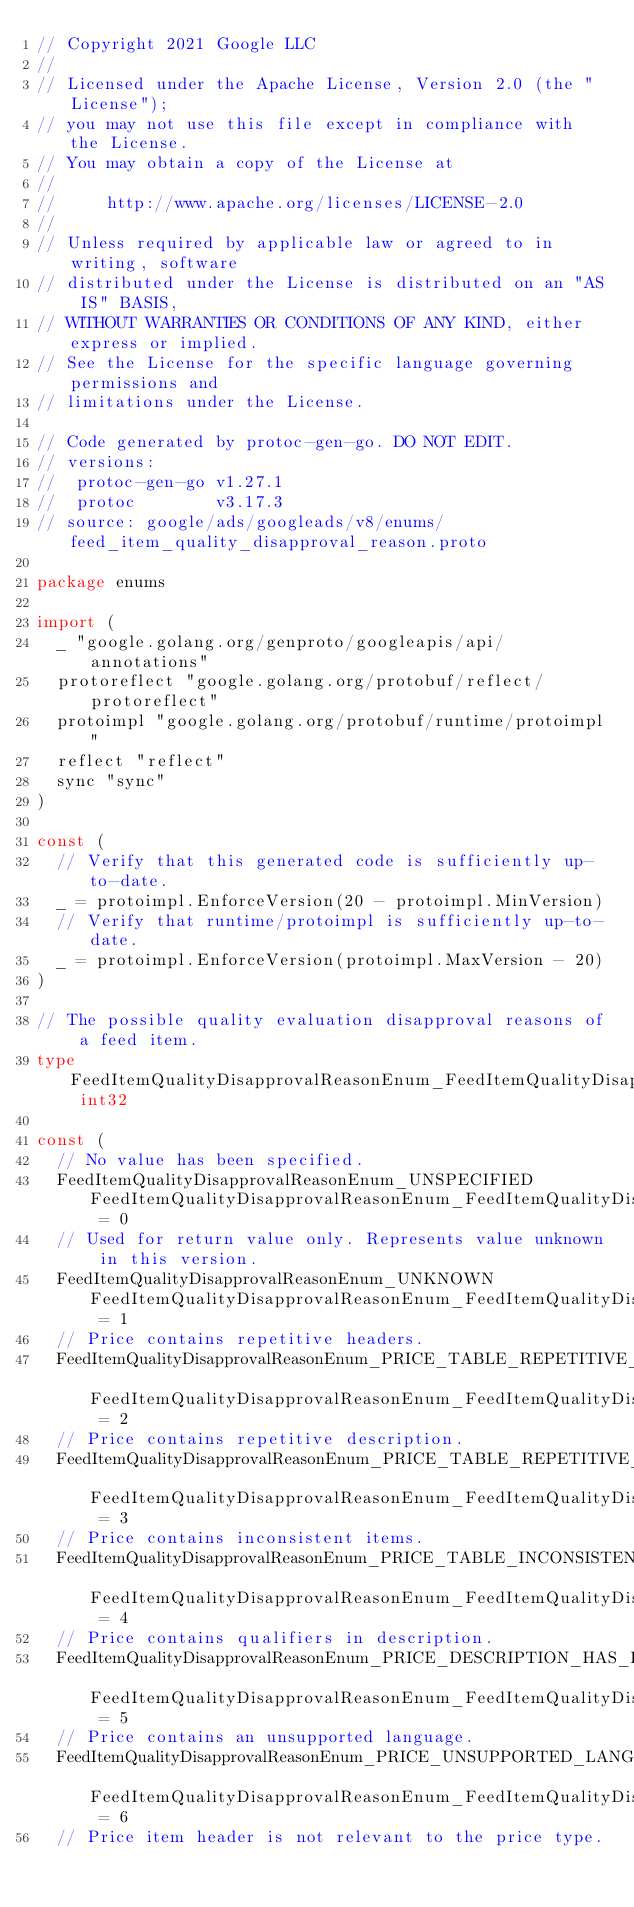Convert code to text. <code><loc_0><loc_0><loc_500><loc_500><_Go_>// Copyright 2021 Google LLC
//
// Licensed under the Apache License, Version 2.0 (the "License");
// you may not use this file except in compliance with the License.
// You may obtain a copy of the License at
//
//     http://www.apache.org/licenses/LICENSE-2.0
//
// Unless required by applicable law or agreed to in writing, software
// distributed under the License is distributed on an "AS IS" BASIS,
// WITHOUT WARRANTIES OR CONDITIONS OF ANY KIND, either express or implied.
// See the License for the specific language governing permissions and
// limitations under the License.

// Code generated by protoc-gen-go. DO NOT EDIT.
// versions:
// 	protoc-gen-go v1.27.1
// 	protoc        v3.17.3
// source: google/ads/googleads/v8/enums/feed_item_quality_disapproval_reason.proto

package enums

import (
	_ "google.golang.org/genproto/googleapis/api/annotations"
	protoreflect "google.golang.org/protobuf/reflect/protoreflect"
	protoimpl "google.golang.org/protobuf/runtime/protoimpl"
	reflect "reflect"
	sync "sync"
)

const (
	// Verify that this generated code is sufficiently up-to-date.
	_ = protoimpl.EnforceVersion(20 - protoimpl.MinVersion)
	// Verify that runtime/protoimpl is sufficiently up-to-date.
	_ = protoimpl.EnforceVersion(protoimpl.MaxVersion - 20)
)

// The possible quality evaluation disapproval reasons of a feed item.
type FeedItemQualityDisapprovalReasonEnum_FeedItemQualityDisapprovalReason int32

const (
	// No value has been specified.
	FeedItemQualityDisapprovalReasonEnum_UNSPECIFIED FeedItemQualityDisapprovalReasonEnum_FeedItemQualityDisapprovalReason = 0
	// Used for return value only. Represents value unknown in this version.
	FeedItemQualityDisapprovalReasonEnum_UNKNOWN FeedItemQualityDisapprovalReasonEnum_FeedItemQualityDisapprovalReason = 1
	// Price contains repetitive headers.
	FeedItemQualityDisapprovalReasonEnum_PRICE_TABLE_REPETITIVE_HEADERS FeedItemQualityDisapprovalReasonEnum_FeedItemQualityDisapprovalReason = 2
	// Price contains repetitive description.
	FeedItemQualityDisapprovalReasonEnum_PRICE_TABLE_REPETITIVE_DESCRIPTION FeedItemQualityDisapprovalReasonEnum_FeedItemQualityDisapprovalReason = 3
	// Price contains inconsistent items.
	FeedItemQualityDisapprovalReasonEnum_PRICE_TABLE_INCONSISTENT_ROWS FeedItemQualityDisapprovalReasonEnum_FeedItemQualityDisapprovalReason = 4
	// Price contains qualifiers in description.
	FeedItemQualityDisapprovalReasonEnum_PRICE_DESCRIPTION_HAS_PRICE_QUALIFIERS FeedItemQualityDisapprovalReasonEnum_FeedItemQualityDisapprovalReason = 5
	// Price contains an unsupported language.
	FeedItemQualityDisapprovalReasonEnum_PRICE_UNSUPPORTED_LANGUAGE FeedItemQualityDisapprovalReasonEnum_FeedItemQualityDisapprovalReason = 6
	// Price item header is not relevant to the price type.</code> 